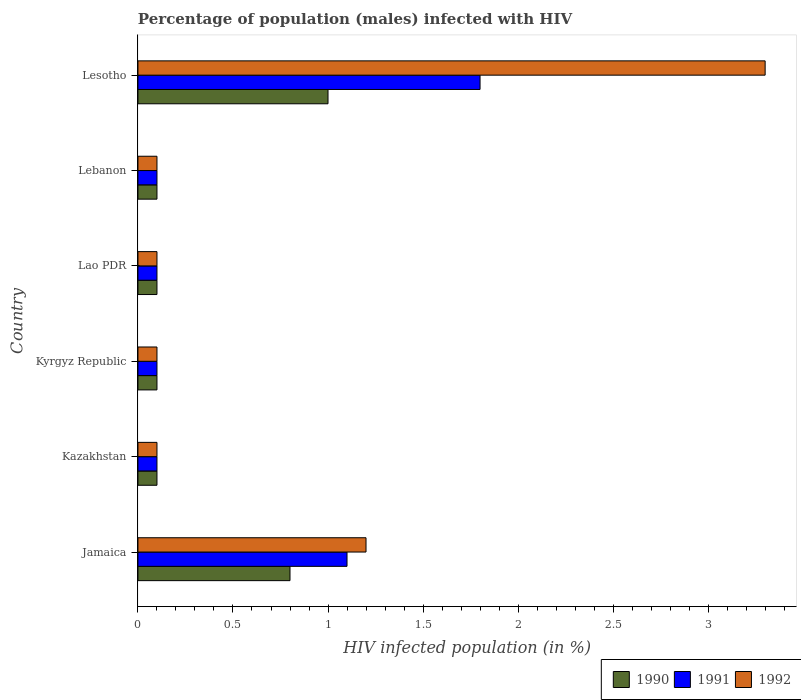Are the number of bars per tick equal to the number of legend labels?
Give a very brief answer. Yes. Are the number of bars on each tick of the Y-axis equal?
Your answer should be compact. Yes. What is the label of the 4th group of bars from the top?
Ensure brevity in your answer.  Kyrgyz Republic. What is the percentage of HIV infected male population in 1991 in Jamaica?
Provide a succinct answer. 1.1. Across all countries, what is the maximum percentage of HIV infected male population in 1992?
Your answer should be compact. 3.3. Across all countries, what is the minimum percentage of HIV infected male population in 1992?
Your answer should be compact. 0.1. In which country was the percentage of HIV infected male population in 1992 maximum?
Make the answer very short. Lesotho. In which country was the percentage of HIV infected male population in 1990 minimum?
Offer a terse response. Kazakhstan. What is the total percentage of HIV infected male population in 1992 in the graph?
Your answer should be compact. 4.9. What is the difference between the percentage of HIV infected male population in 1991 in Lao PDR and the percentage of HIV infected male population in 1990 in Kazakhstan?
Your answer should be compact. 0. What is the average percentage of HIV infected male population in 1992 per country?
Your answer should be very brief. 0.82. What is the ratio of the percentage of HIV infected male population in 1992 in Jamaica to that in Lao PDR?
Give a very brief answer. 12. Is the difference between the percentage of HIV infected male population in 1992 in Kazakhstan and Lao PDR greater than the difference between the percentage of HIV infected male population in 1991 in Kazakhstan and Lao PDR?
Offer a terse response. No. What is the difference between the highest and the second highest percentage of HIV infected male population in 1990?
Provide a succinct answer. 0.2. In how many countries, is the percentage of HIV infected male population in 1991 greater than the average percentage of HIV infected male population in 1991 taken over all countries?
Offer a terse response. 2. Is it the case that in every country, the sum of the percentage of HIV infected male population in 1991 and percentage of HIV infected male population in 1992 is greater than the percentage of HIV infected male population in 1990?
Offer a terse response. Yes. How many bars are there?
Your response must be concise. 18. Are all the bars in the graph horizontal?
Provide a succinct answer. Yes. How many countries are there in the graph?
Give a very brief answer. 6. What is the difference between two consecutive major ticks on the X-axis?
Make the answer very short. 0.5. Are the values on the major ticks of X-axis written in scientific E-notation?
Your response must be concise. No. Does the graph contain grids?
Provide a short and direct response. No. Where does the legend appear in the graph?
Your answer should be compact. Bottom right. How are the legend labels stacked?
Keep it short and to the point. Horizontal. What is the title of the graph?
Keep it short and to the point. Percentage of population (males) infected with HIV. Does "1979" appear as one of the legend labels in the graph?
Your answer should be very brief. No. What is the label or title of the X-axis?
Make the answer very short. HIV infected population (in %). What is the HIV infected population (in %) of 1990 in Jamaica?
Your answer should be compact. 0.8. What is the HIV infected population (in %) in 1991 in Kazakhstan?
Offer a terse response. 0.1. What is the HIV infected population (in %) in 1992 in Kazakhstan?
Your response must be concise. 0.1. What is the HIV infected population (in %) of 1990 in Kyrgyz Republic?
Ensure brevity in your answer.  0.1. What is the HIV infected population (in %) in 1991 in Kyrgyz Republic?
Give a very brief answer. 0.1. What is the HIV infected population (in %) of 1991 in Lao PDR?
Offer a terse response. 0.1. What is the HIV infected population (in %) in 1992 in Lao PDR?
Offer a terse response. 0.1. What is the HIV infected population (in %) of 1990 in Lebanon?
Provide a short and direct response. 0.1. What is the HIV infected population (in %) of 1991 in Lebanon?
Your response must be concise. 0.1. What is the HIV infected population (in %) of 1992 in Lebanon?
Your response must be concise. 0.1. What is the HIV infected population (in %) in 1991 in Lesotho?
Make the answer very short. 1.8. What is the HIV infected population (in %) in 1992 in Lesotho?
Keep it short and to the point. 3.3. Across all countries, what is the maximum HIV infected population (in %) in 1991?
Your answer should be very brief. 1.8. Across all countries, what is the minimum HIV infected population (in %) of 1990?
Your response must be concise. 0.1. What is the total HIV infected population (in %) in 1990 in the graph?
Give a very brief answer. 2.2. What is the total HIV infected population (in %) of 1992 in the graph?
Your answer should be very brief. 4.9. What is the difference between the HIV infected population (in %) of 1990 in Jamaica and that in Kazakhstan?
Offer a very short reply. 0.7. What is the difference between the HIV infected population (in %) of 1991 in Jamaica and that in Kyrgyz Republic?
Provide a succinct answer. 1. What is the difference between the HIV infected population (in %) of 1990 in Jamaica and that in Lao PDR?
Keep it short and to the point. 0.7. What is the difference between the HIV infected population (in %) of 1991 in Jamaica and that in Lao PDR?
Give a very brief answer. 1. What is the difference between the HIV infected population (in %) in 1992 in Jamaica and that in Lao PDR?
Provide a succinct answer. 1.1. What is the difference between the HIV infected population (in %) of 1990 in Jamaica and that in Lebanon?
Provide a succinct answer. 0.7. What is the difference between the HIV infected population (in %) of 1992 in Jamaica and that in Lebanon?
Ensure brevity in your answer.  1.1. What is the difference between the HIV infected population (in %) in 1990 in Jamaica and that in Lesotho?
Ensure brevity in your answer.  -0.2. What is the difference between the HIV infected population (in %) in 1991 in Jamaica and that in Lesotho?
Your response must be concise. -0.7. What is the difference between the HIV infected population (in %) of 1992 in Jamaica and that in Lesotho?
Your response must be concise. -2.1. What is the difference between the HIV infected population (in %) of 1991 in Kazakhstan and that in Kyrgyz Republic?
Provide a short and direct response. 0. What is the difference between the HIV infected population (in %) of 1992 in Kazakhstan and that in Kyrgyz Republic?
Provide a short and direct response. 0. What is the difference between the HIV infected population (in %) of 1991 in Kazakhstan and that in Lao PDR?
Your answer should be compact. 0. What is the difference between the HIV infected population (in %) of 1992 in Kazakhstan and that in Lao PDR?
Offer a terse response. 0. What is the difference between the HIV infected population (in %) of 1990 in Kazakhstan and that in Lebanon?
Your response must be concise. 0. What is the difference between the HIV infected population (in %) in 1991 in Kazakhstan and that in Lebanon?
Give a very brief answer. 0. What is the difference between the HIV infected population (in %) in 1990 in Kazakhstan and that in Lesotho?
Your answer should be very brief. -0.9. What is the difference between the HIV infected population (in %) of 1992 in Kazakhstan and that in Lesotho?
Give a very brief answer. -3.2. What is the difference between the HIV infected population (in %) of 1991 in Kyrgyz Republic and that in Lebanon?
Keep it short and to the point. 0. What is the difference between the HIV infected population (in %) of 1992 in Kyrgyz Republic and that in Lebanon?
Offer a terse response. 0. What is the difference between the HIV infected population (in %) in 1992 in Kyrgyz Republic and that in Lesotho?
Your response must be concise. -3.2. What is the difference between the HIV infected population (in %) in 1991 in Lao PDR and that in Lebanon?
Your answer should be very brief. 0. What is the difference between the HIV infected population (in %) of 1990 in Lao PDR and that in Lesotho?
Ensure brevity in your answer.  -0.9. What is the difference between the HIV infected population (in %) in 1992 in Lao PDR and that in Lesotho?
Offer a terse response. -3.2. What is the difference between the HIV infected population (in %) of 1990 in Jamaica and the HIV infected population (in %) of 1991 in Kazakhstan?
Ensure brevity in your answer.  0.7. What is the difference between the HIV infected population (in %) of 1990 in Jamaica and the HIV infected population (in %) of 1992 in Kazakhstan?
Give a very brief answer. 0.7. What is the difference between the HIV infected population (in %) of 1990 in Jamaica and the HIV infected population (in %) of 1991 in Kyrgyz Republic?
Your answer should be compact. 0.7. What is the difference between the HIV infected population (in %) in 1990 in Jamaica and the HIV infected population (in %) in 1991 in Lao PDR?
Keep it short and to the point. 0.7. What is the difference between the HIV infected population (in %) in 1991 in Jamaica and the HIV infected population (in %) in 1992 in Lao PDR?
Provide a short and direct response. 1. What is the difference between the HIV infected population (in %) of 1990 in Jamaica and the HIV infected population (in %) of 1992 in Lebanon?
Offer a very short reply. 0.7. What is the difference between the HIV infected population (in %) of 1990 in Jamaica and the HIV infected population (in %) of 1991 in Lesotho?
Provide a short and direct response. -1. What is the difference between the HIV infected population (in %) in 1990 in Jamaica and the HIV infected population (in %) in 1992 in Lesotho?
Provide a short and direct response. -2.5. What is the difference between the HIV infected population (in %) of 1991 in Kazakhstan and the HIV infected population (in %) of 1992 in Kyrgyz Republic?
Ensure brevity in your answer.  0. What is the difference between the HIV infected population (in %) of 1990 in Kazakhstan and the HIV infected population (in %) of 1991 in Lao PDR?
Offer a very short reply. 0. What is the difference between the HIV infected population (in %) in 1990 in Kazakhstan and the HIV infected population (in %) in 1991 in Lebanon?
Ensure brevity in your answer.  0. What is the difference between the HIV infected population (in %) in 1991 in Kazakhstan and the HIV infected population (in %) in 1992 in Lebanon?
Ensure brevity in your answer.  0. What is the difference between the HIV infected population (in %) in 1990 in Kazakhstan and the HIV infected population (in %) in 1991 in Lesotho?
Provide a succinct answer. -1.7. What is the difference between the HIV infected population (in %) in 1990 in Kazakhstan and the HIV infected population (in %) in 1992 in Lesotho?
Give a very brief answer. -3.2. What is the difference between the HIV infected population (in %) in 1991 in Kazakhstan and the HIV infected population (in %) in 1992 in Lesotho?
Ensure brevity in your answer.  -3.2. What is the difference between the HIV infected population (in %) in 1991 in Kyrgyz Republic and the HIV infected population (in %) in 1992 in Lao PDR?
Make the answer very short. 0. What is the difference between the HIV infected population (in %) of 1991 in Kyrgyz Republic and the HIV infected population (in %) of 1992 in Lebanon?
Offer a terse response. 0. What is the difference between the HIV infected population (in %) of 1991 in Kyrgyz Republic and the HIV infected population (in %) of 1992 in Lesotho?
Your response must be concise. -3.2. What is the difference between the HIV infected population (in %) in 1990 in Lao PDR and the HIV infected population (in %) in 1991 in Lebanon?
Offer a very short reply. 0. What is the difference between the HIV infected population (in %) of 1991 in Lao PDR and the HIV infected population (in %) of 1992 in Lebanon?
Make the answer very short. 0. What is the difference between the HIV infected population (in %) of 1990 in Lao PDR and the HIV infected population (in %) of 1991 in Lesotho?
Provide a succinct answer. -1.7. What is the difference between the HIV infected population (in %) of 1991 in Lao PDR and the HIV infected population (in %) of 1992 in Lesotho?
Ensure brevity in your answer.  -3.2. What is the difference between the HIV infected population (in %) of 1990 in Lebanon and the HIV infected population (in %) of 1992 in Lesotho?
Your answer should be very brief. -3.2. What is the difference between the HIV infected population (in %) of 1991 in Lebanon and the HIV infected population (in %) of 1992 in Lesotho?
Your answer should be compact. -3.2. What is the average HIV infected population (in %) in 1990 per country?
Give a very brief answer. 0.37. What is the average HIV infected population (in %) of 1991 per country?
Your response must be concise. 0.55. What is the average HIV infected population (in %) of 1992 per country?
Provide a succinct answer. 0.82. What is the difference between the HIV infected population (in %) in 1990 and HIV infected population (in %) in 1991 in Jamaica?
Provide a short and direct response. -0.3. What is the difference between the HIV infected population (in %) of 1991 and HIV infected population (in %) of 1992 in Jamaica?
Provide a short and direct response. -0.1. What is the difference between the HIV infected population (in %) in 1990 and HIV infected population (in %) in 1991 in Kazakhstan?
Keep it short and to the point. 0. What is the difference between the HIV infected population (in %) in 1990 and HIV infected population (in %) in 1992 in Kazakhstan?
Your answer should be very brief. 0. What is the difference between the HIV infected population (in %) of 1991 and HIV infected population (in %) of 1992 in Kazakhstan?
Give a very brief answer. 0. What is the difference between the HIV infected population (in %) of 1990 and HIV infected population (in %) of 1991 in Kyrgyz Republic?
Your answer should be very brief. 0. What is the difference between the HIV infected population (in %) of 1991 and HIV infected population (in %) of 1992 in Kyrgyz Republic?
Provide a short and direct response. 0. What is the difference between the HIV infected population (in %) in 1991 and HIV infected population (in %) in 1992 in Lebanon?
Provide a short and direct response. 0. What is the difference between the HIV infected population (in %) of 1990 and HIV infected population (in %) of 1992 in Lesotho?
Your response must be concise. -2.3. What is the ratio of the HIV infected population (in %) in 1991 in Jamaica to that in Kyrgyz Republic?
Ensure brevity in your answer.  11. What is the ratio of the HIV infected population (in %) in 1992 in Jamaica to that in Kyrgyz Republic?
Give a very brief answer. 12. What is the ratio of the HIV infected population (in %) of 1990 in Jamaica to that in Lao PDR?
Provide a succinct answer. 8. What is the ratio of the HIV infected population (in %) of 1992 in Jamaica to that in Lao PDR?
Your answer should be very brief. 12. What is the ratio of the HIV infected population (in %) in 1990 in Jamaica to that in Lebanon?
Your answer should be compact. 8. What is the ratio of the HIV infected population (in %) of 1991 in Jamaica to that in Lebanon?
Your response must be concise. 11. What is the ratio of the HIV infected population (in %) of 1991 in Jamaica to that in Lesotho?
Offer a very short reply. 0.61. What is the ratio of the HIV infected population (in %) in 1992 in Jamaica to that in Lesotho?
Offer a terse response. 0.36. What is the ratio of the HIV infected population (in %) in 1990 in Kazakhstan to that in Lao PDR?
Offer a very short reply. 1. What is the ratio of the HIV infected population (in %) in 1990 in Kazakhstan to that in Lesotho?
Provide a short and direct response. 0.1. What is the ratio of the HIV infected population (in %) in 1991 in Kazakhstan to that in Lesotho?
Give a very brief answer. 0.06. What is the ratio of the HIV infected population (in %) in 1992 in Kazakhstan to that in Lesotho?
Your response must be concise. 0.03. What is the ratio of the HIV infected population (in %) of 1990 in Kyrgyz Republic to that in Lao PDR?
Your answer should be compact. 1. What is the ratio of the HIV infected population (in %) in 1991 in Kyrgyz Republic to that in Lao PDR?
Give a very brief answer. 1. What is the ratio of the HIV infected population (in %) of 1992 in Kyrgyz Republic to that in Lao PDR?
Provide a succinct answer. 1. What is the ratio of the HIV infected population (in %) in 1990 in Kyrgyz Republic to that in Lebanon?
Provide a succinct answer. 1. What is the ratio of the HIV infected population (in %) in 1991 in Kyrgyz Republic to that in Lebanon?
Your answer should be very brief. 1. What is the ratio of the HIV infected population (in %) in 1991 in Kyrgyz Republic to that in Lesotho?
Offer a very short reply. 0.06. What is the ratio of the HIV infected population (in %) in 1992 in Kyrgyz Republic to that in Lesotho?
Your answer should be compact. 0.03. What is the ratio of the HIV infected population (in %) of 1992 in Lao PDR to that in Lebanon?
Provide a short and direct response. 1. What is the ratio of the HIV infected population (in %) in 1991 in Lao PDR to that in Lesotho?
Provide a succinct answer. 0.06. What is the ratio of the HIV infected population (in %) in 1992 in Lao PDR to that in Lesotho?
Make the answer very short. 0.03. What is the ratio of the HIV infected population (in %) of 1991 in Lebanon to that in Lesotho?
Give a very brief answer. 0.06. What is the ratio of the HIV infected population (in %) of 1992 in Lebanon to that in Lesotho?
Ensure brevity in your answer.  0.03. What is the difference between the highest and the second highest HIV infected population (in %) of 1990?
Keep it short and to the point. 0.2. What is the difference between the highest and the second highest HIV infected population (in %) of 1992?
Your answer should be compact. 2.1. What is the difference between the highest and the lowest HIV infected population (in %) of 1990?
Provide a succinct answer. 0.9. What is the difference between the highest and the lowest HIV infected population (in %) of 1991?
Give a very brief answer. 1.7. What is the difference between the highest and the lowest HIV infected population (in %) in 1992?
Your answer should be compact. 3.2. 